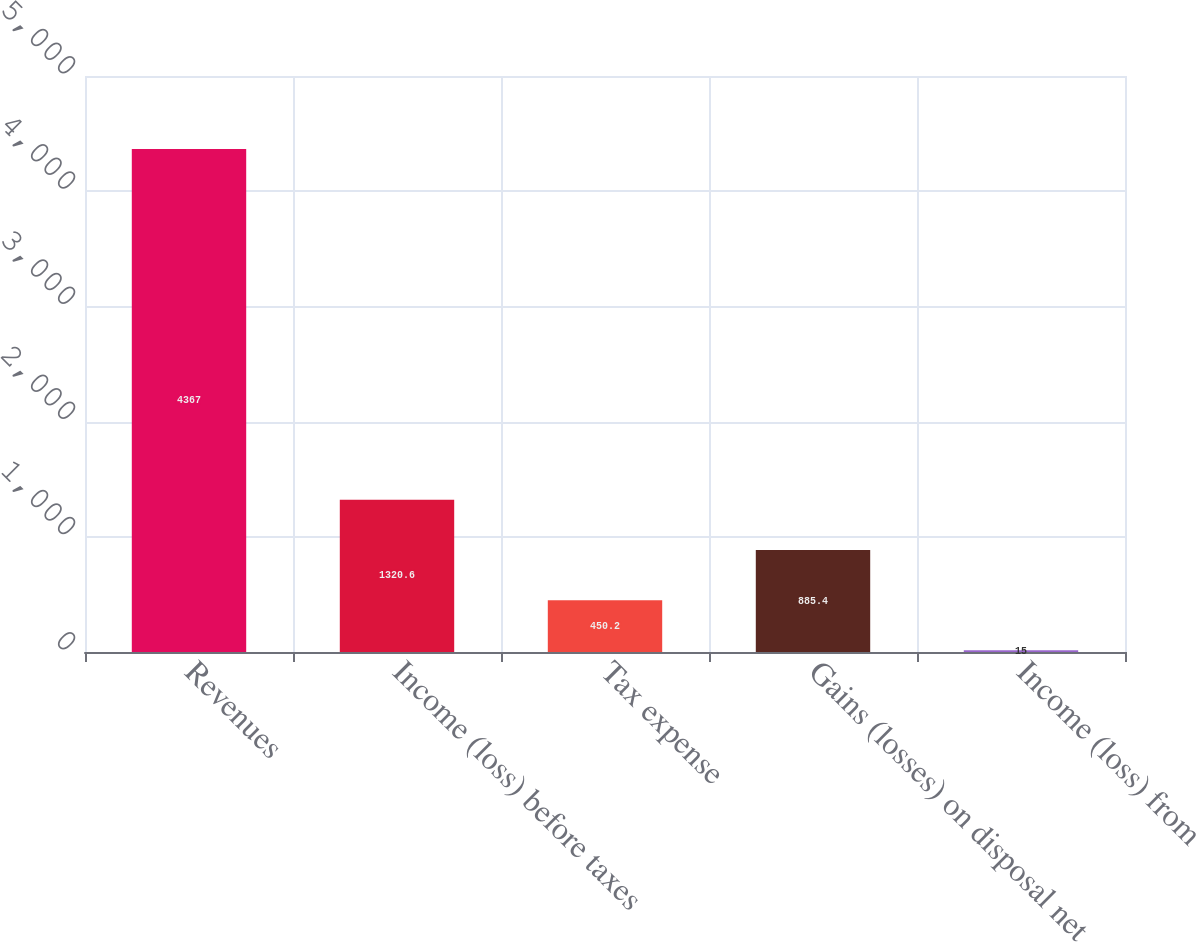Convert chart to OTSL. <chart><loc_0><loc_0><loc_500><loc_500><bar_chart><fcel>Revenues<fcel>Income (loss) before taxes<fcel>Tax expense<fcel>Gains (losses) on disposal net<fcel>Income (loss) from<nl><fcel>4367<fcel>1320.6<fcel>450.2<fcel>885.4<fcel>15<nl></chart> 